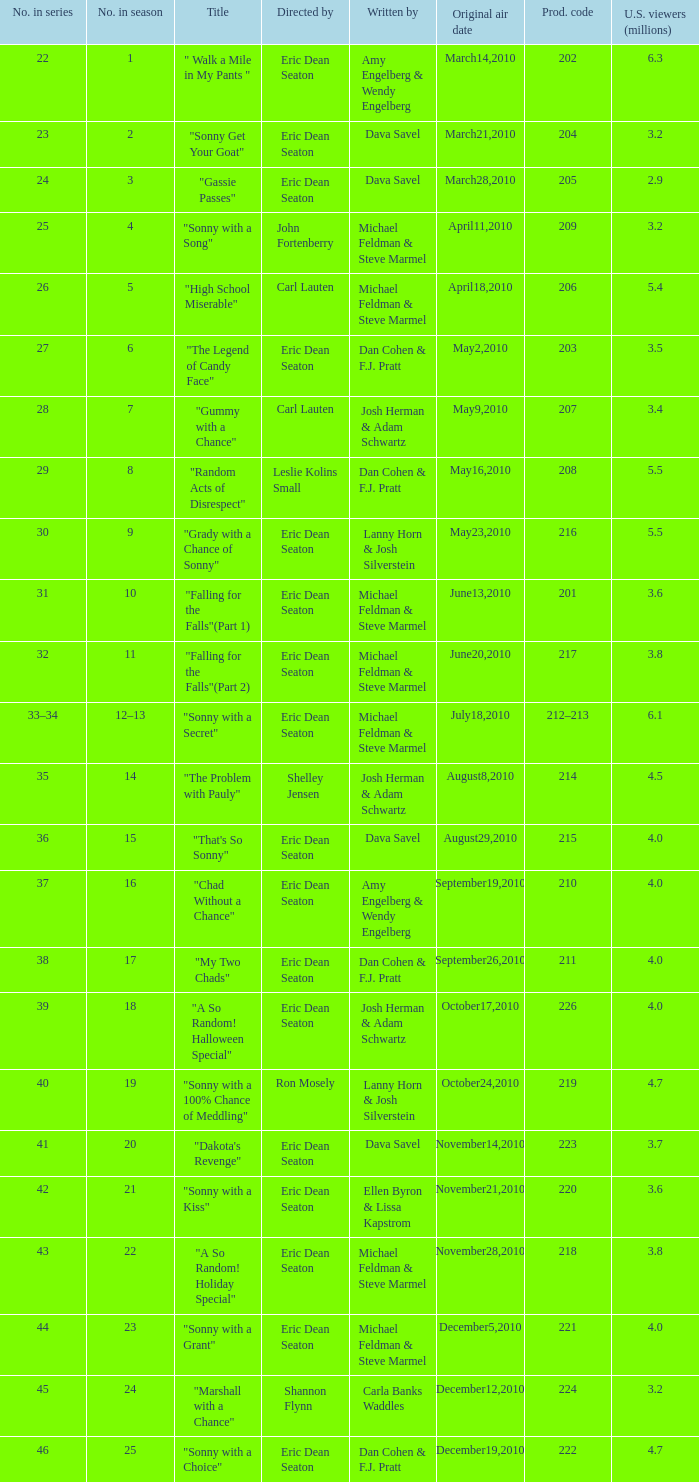3 million u.s. viewers? Eric Dean Seaton. 